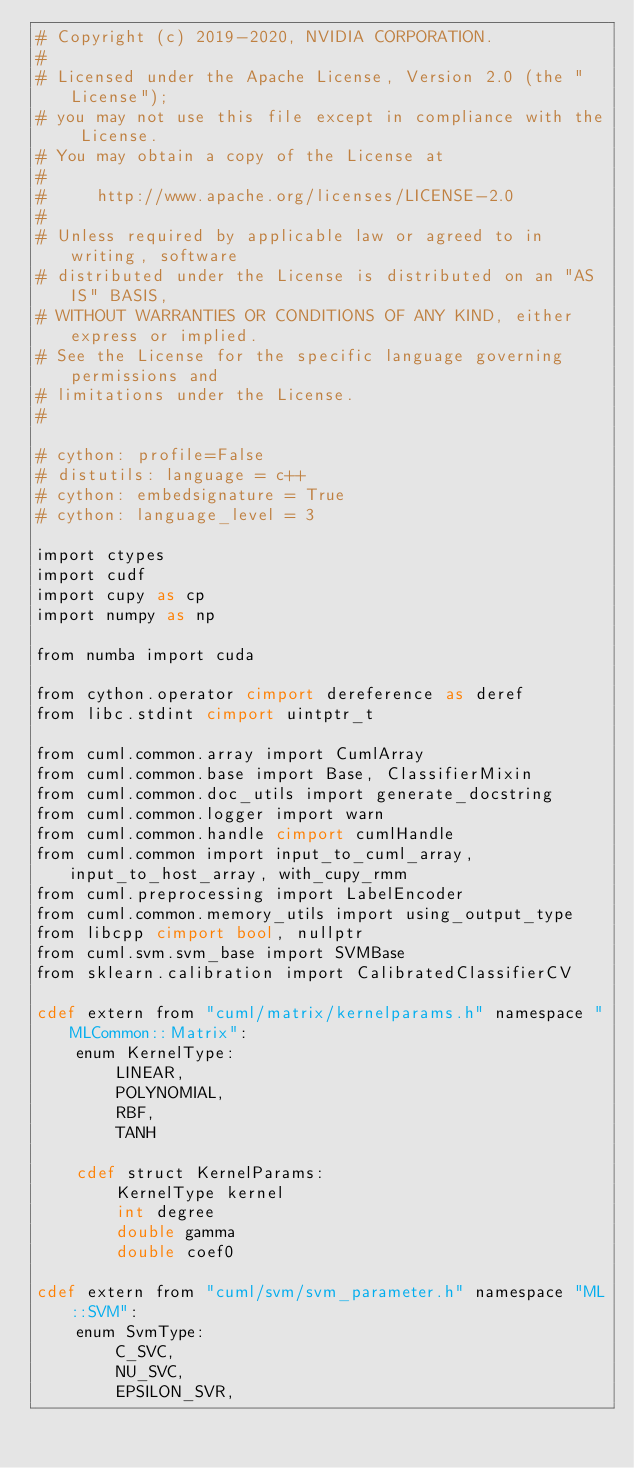Convert code to text. <code><loc_0><loc_0><loc_500><loc_500><_Cython_># Copyright (c) 2019-2020, NVIDIA CORPORATION.
#
# Licensed under the Apache License, Version 2.0 (the "License");
# you may not use this file except in compliance with the License.
# You may obtain a copy of the License at
#
#     http://www.apache.org/licenses/LICENSE-2.0
#
# Unless required by applicable law or agreed to in writing, software
# distributed under the License is distributed on an "AS IS" BASIS,
# WITHOUT WARRANTIES OR CONDITIONS OF ANY KIND, either express or implied.
# See the License for the specific language governing permissions and
# limitations under the License.
#

# cython: profile=False
# distutils: language = c++
# cython: embedsignature = True
# cython: language_level = 3

import ctypes
import cudf
import cupy as cp
import numpy as np

from numba import cuda

from cython.operator cimport dereference as deref
from libc.stdint cimport uintptr_t

from cuml.common.array import CumlArray
from cuml.common.base import Base, ClassifierMixin
from cuml.common.doc_utils import generate_docstring
from cuml.common.logger import warn
from cuml.common.handle cimport cumlHandle
from cuml.common import input_to_cuml_array, input_to_host_array, with_cupy_rmm
from cuml.preprocessing import LabelEncoder
from cuml.common.memory_utils import using_output_type
from libcpp cimport bool, nullptr
from cuml.svm.svm_base import SVMBase
from sklearn.calibration import CalibratedClassifierCV

cdef extern from "cuml/matrix/kernelparams.h" namespace "MLCommon::Matrix":
    enum KernelType:
        LINEAR,
        POLYNOMIAL,
        RBF,
        TANH

    cdef struct KernelParams:
        KernelType kernel
        int degree
        double gamma
        double coef0

cdef extern from "cuml/svm/svm_parameter.h" namespace "ML::SVM":
    enum SvmType:
        C_SVC,
        NU_SVC,
        EPSILON_SVR,</code> 